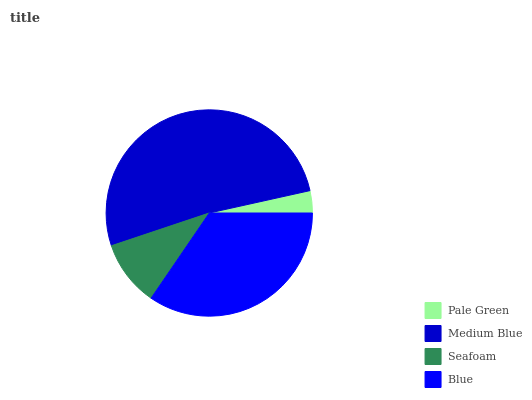Is Pale Green the minimum?
Answer yes or no. Yes. Is Medium Blue the maximum?
Answer yes or no. Yes. Is Seafoam the minimum?
Answer yes or no. No. Is Seafoam the maximum?
Answer yes or no. No. Is Medium Blue greater than Seafoam?
Answer yes or no. Yes. Is Seafoam less than Medium Blue?
Answer yes or no. Yes. Is Seafoam greater than Medium Blue?
Answer yes or no. No. Is Medium Blue less than Seafoam?
Answer yes or no. No. Is Blue the high median?
Answer yes or no. Yes. Is Seafoam the low median?
Answer yes or no. Yes. Is Pale Green the high median?
Answer yes or no. No. Is Blue the low median?
Answer yes or no. No. 